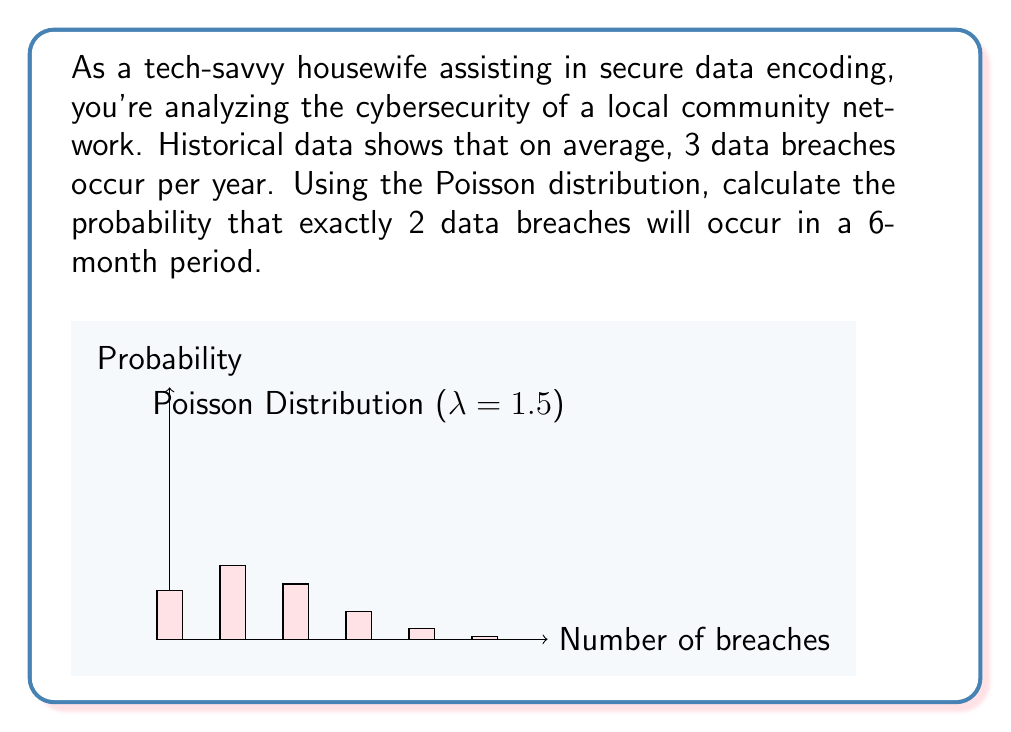Show me your answer to this math problem. Let's approach this step-by-step:

1) The Poisson distribution is given by the formula:

   $$P(X = k) = \frac{e^{-\lambda} \lambda^k}{k!}$$

   where $\lambda$ is the average number of events in the given time period, and $k$ is the number of events we're calculating the probability for.

2) We're given that there are 3 breaches per year on average. For a 6-month period, this becomes:

   $$\lambda = 3 \cdot \frac{6}{12} = 1.5$$

3) We want to calculate the probability of exactly 2 breaches, so $k = 2$.

4) Plugging these values into the Poisson formula:

   $$P(X = 2) = \frac{e^{-1.5} 1.5^2}{2!}$$

5) Let's calculate this step-by-step:
   
   $$\begin{align}
   P(X = 2) &= \frac{e^{-1.5} \cdot 1.5^2}{2!} \\
   &= \frac{0.22313 \cdot 2.25}{2} \\
   &= 0.25102
   \end{align}$$

6) Converting to a percentage:

   $$0.25102 \cdot 100\% = 25.102\%$$

Therefore, the probability of exactly 2 data breaches occurring in a 6-month period is approximately 25.102%.
Answer: $25.102\%$ 